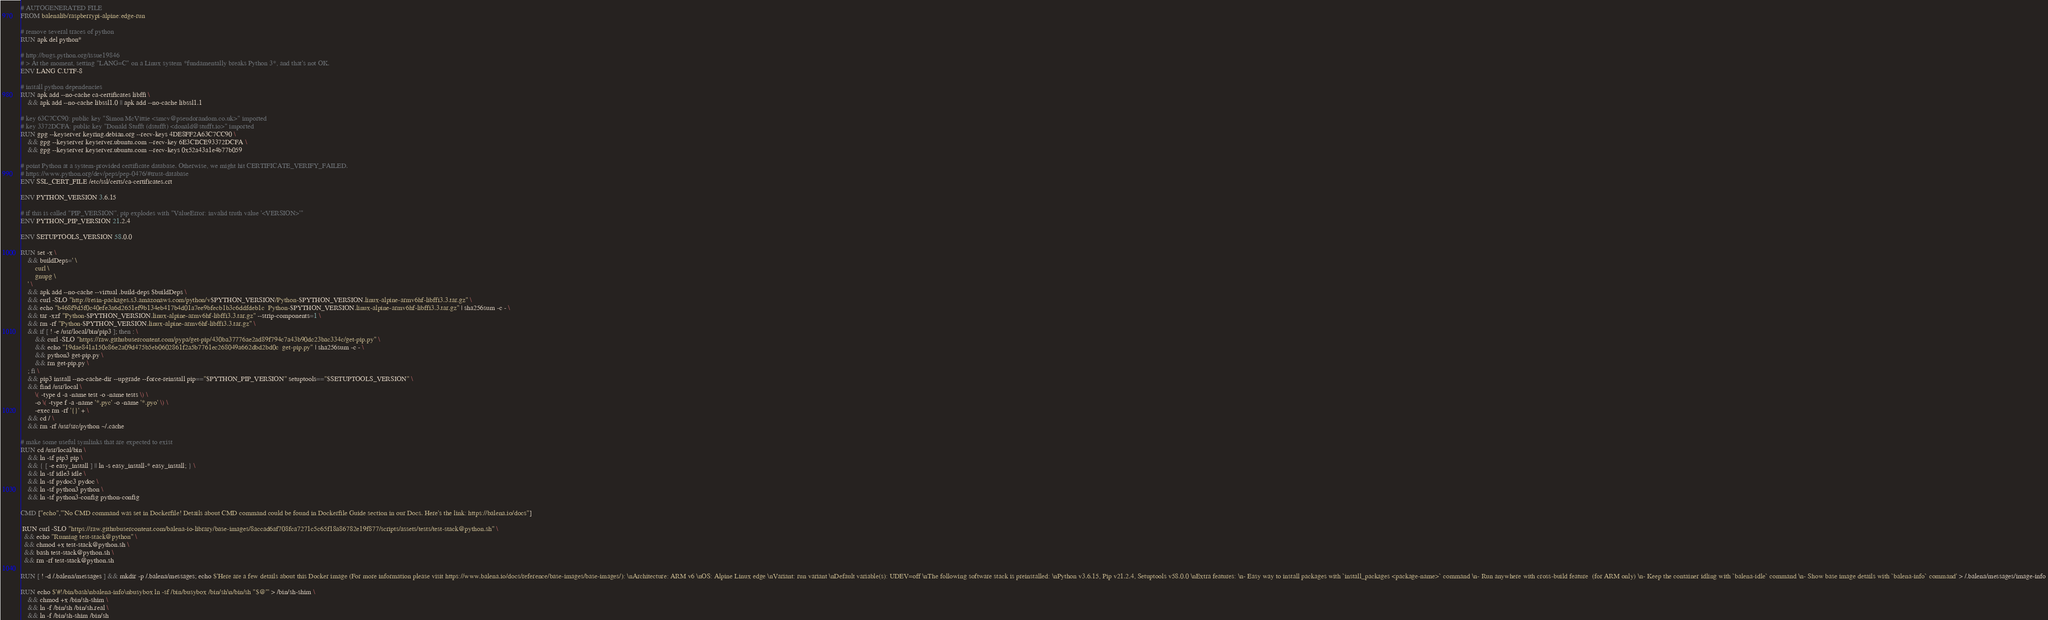Convert code to text. <code><loc_0><loc_0><loc_500><loc_500><_Dockerfile_># AUTOGENERATED FILE
FROM balenalib/raspberrypi-alpine:edge-run

# remove several traces of python
RUN apk del python*

# http://bugs.python.org/issue19846
# > At the moment, setting "LANG=C" on a Linux system *fundamentally breaks Python 3*, and that's not OK.
ENV LANG C.UTF-8

# install python dependencies
RUN apk add --no-cache ca-certificates libffi \
	&& apk add --no-cache libssl1.0 || apk add --no-cache libssl1.1

# key 63C7CC90: public key "Simon McVittie <smcv@pseudorandom.co.uk>" imported
# key 3372DCFA: public key "Donald Stufft (dstufft) <donald@stufft.io>" imported
RUN gpg --keyserver keyring.debian.org --recv-keys 4DE8FF2A63C7CC90 \
	&& gpg --keyserver keyserver.ubuntu.com --recv-key 6E3CBCE93372DCFA \
	&& gpg --keyserver keyserver.ubuntu.com --recv-keys 0x52a43a1e4b77b059

# point Python at a system-provided certificate database. Otherwise, we might hit CERTIFICATE_VERIFY_FAILED.
# https://www.python.org/dev/peps/pep-0476/#trust-database
ENV SSL_CERT_FILE /etc/ssl/certs/ca-certificates.crt

ENV PYTHON_VERSION 3.6.15

# if this is called "PIP_VERSION", pip explodes with "ValueError: invalid truth value '<VERSION>'"
ENV PYTHON_PIP_VERSION 21.2.4

ENV SETUPTOOLS_VERSION 58.0.0

RUN set -x \
	&& buildDeps=' \
		curl \
		gnupg \
	' \
	&& apk add --no-cache --virtual .build-deps $buildDeps \
	&& curl -SLO "http://resin-packages.s3.amazonaws.com/python/v$PYTHON_VERSION/Python-$PYTHON_VERSION.linux-alpine-armv6hf-libffi3.3.tar.gz" \
	&& echo "b468f9d5f0c40efe3a6d2651ef9b134eb417b4d01a7ee9bfecb1b3c6ddfdeb1c  Python-$PYTHON_VERSION.linux-alpine-armv6hf-libffi3.3.tar.gz" | sha256sum -c - \
	&& tar -xzf "Python-$PYTHON_VERSION.linux-alpine-armv6hf-libffi3.3.tar.gz" --strip-components=1 \
	&& rm -rf "Python-$PYTHON_VERSION.linux-alpine-armv6hf-libffi3.3.tar.gz" \
	&& if [ ! -e /usr/local/bin/pip3 ]; then : \
		&& curl -SLO "https://raw.githubusercontent.com/pypa/get-pip/430ba37776ae2ad89f794c7a43b90dc23bac334c/get-pip.py" \
		&& echo "19dae841a150c86e2a09d475b5eb0602861f2a5b7761ec268049a662dbd2bd0c  get-pip.py" | sha256sum -c - \
		&& python3 get-pip.py \
		&& rm get-pip.py \
	; fi \
	&& pip3 install --no-cache-dir --upgrade --force-reinstall pip=="$PYTHON_PIP_VERSION" setuptools=="$SETUPTOOLS_VERSION" \
	&& find /usr/local \
		\( -type d -a -name test -o -name tests \) \
		-o \( -type f -a -name '*.pyc' -o -name '*.pyo' \) \
		-exec rm -rf '{}' + \
	&& cd / \
	&& rm -rf /usr/src/python ~/.cache

# make some useful symlinks that are expected to exist
RUN cd /usr/local/bin \
	&& ln -sf pip3 pip \
	&& { [ -e easy_install ] || ln -s easy_install-* easy_install; } \
	&& ln -sf idle3 idle \
	&& ln -sf pydoc3 pydoc \
	&& ln -sf python3 python \
	&& ln -sf python3-config python-config

CMD ["echo","'No CMD command was set in Dockerfile! Details about CMD command could be found in Dockerfile Guide section in our Docs. Here's the link: https://balena.io/docs"]

 RUN curl -SLO "https://raw.githubusercontent.com/balena-io-library/base-images/8accad6af708fca7271c5c65f18a86782e19f877/scripts/assets/tests/test-stack@python.sh" \
  && echo "Running test-stack@python" \
  && chmod +x test-stack@python.sh \
  && bash test-stack@python.sh \
  && rm -rf test-stack@python.sh 

RUN [ ! -d /.balena/messages ] && mkdir -p /.balena/messages; echo $'Here are a few details about this Docker image (For more information please visit https://www.balena.io/docs/reference/base-images/base-images/): \nArchitecture: ARM v6 \nOS: Alpine Linux edge \nVariant: run variant \nDefault variable(s): UDEV=off \nThe following software stack is preinstalled: \nPython v3.6.15, Pip v21.2.4, Setuptools v58.0.0 \nExtra features: \n- Easy way to install packages with `install_packages <package-name>` command \n- Run anywhere with cross-build feature  (for ARM only) \n- Keep the container idling with `balena-idle` command \n- Show base image details with `balena-info` command' > /.balena/messages/image-info

RUN echo $'#!/bin/bash\nbalena-info\nbusybox ln -sf /bin/busybox /bin/sh\n/bin/sh "$@"' > /bin/sh-shim \
	&& chmod +x /bin/sh-shim \
	&& ln -f /bin/sh /bin/sh.real \
	&& ln -f /bin/sh-shim /bin/sh</code> 